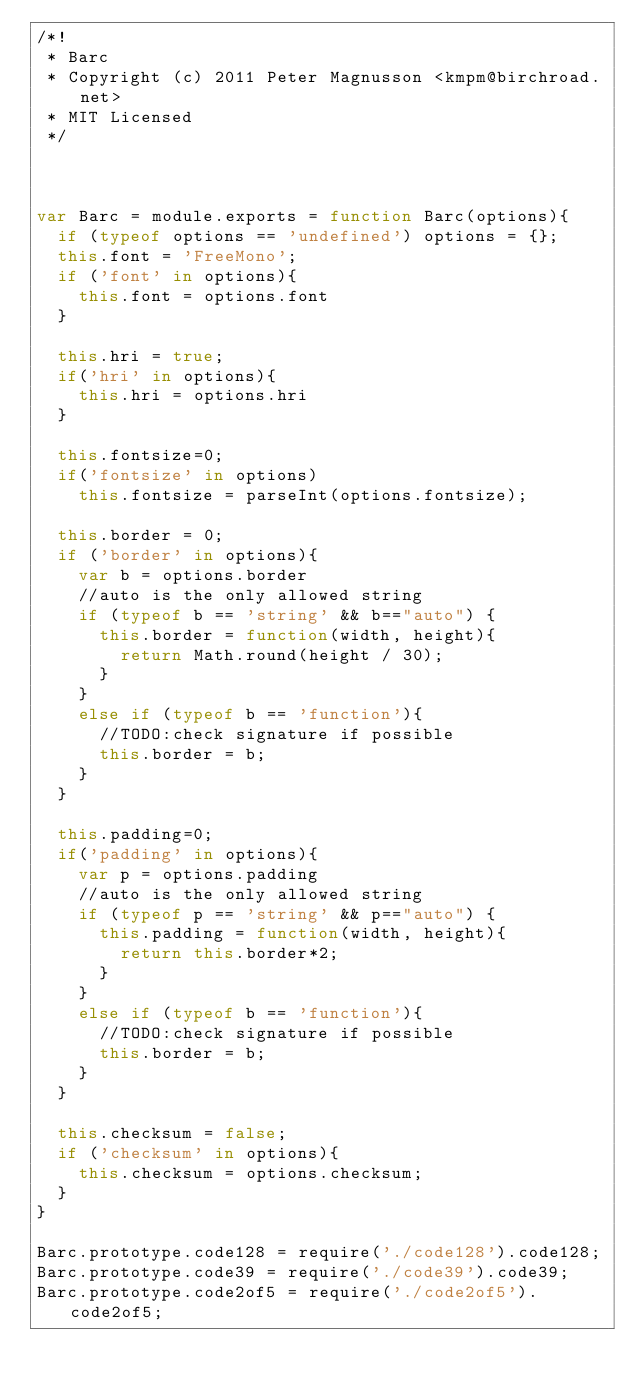Convert code to text. <code><loc_0><loc_0><loc_500><loc_500><_JavaScript_>/*!
 * Barc
 * Copyright (c) 2011 Peter Magnusson <kmpm@birchroad.net>
 * MIT Licensed
 */



var Barc = module.exports = function Barc(options){
	if (typeof options == 'undefined') options = {};
	this.font = 'FreeMono';
	if ('font' in options){
		this.font = options.font
	}

	this.hri = true;
	if('hri' in options){
		this.hri = options.hri
	}

	this.fontsize=0;
	if('fontsize' in options)
		this.fontsize = parseInt(options.fontsize);

	this.border = 0;
	if ('border' in options){
		var b = options.border
		//auto is the only allowed string
		if (typeof b == 'string' && b=="auto") {
			this.border = function(width, height){
				return Math.round(height / 30);
			}
		}
		else if (typeof b == 'function'){
			//TODO:check signature if possible
			this.border = b;
		}
	}

	this.padding=0;
	if('padding' in options){
		var p = options.padding
		//auto is the only allowed string
		if (typeof p == 'string' && p=="auto") {
			this.padding = function(width, height){
				return this.border*2;
			}
		}
		else if (typeof b == 'function'){
			//TODO:check signature if possible
			this.border = b;
		}
	}

	this.checksum = false;
	if ('checksum' in options){
	  this.checksum = options.checksum;
	}
}

Barc.prototype.code128 = require('./code128').code128;
Barc.prototype.code39 = require('./code39').code39;
Barc.prototype.code2of5 = require('./code2of5').code2of5;
</code> 